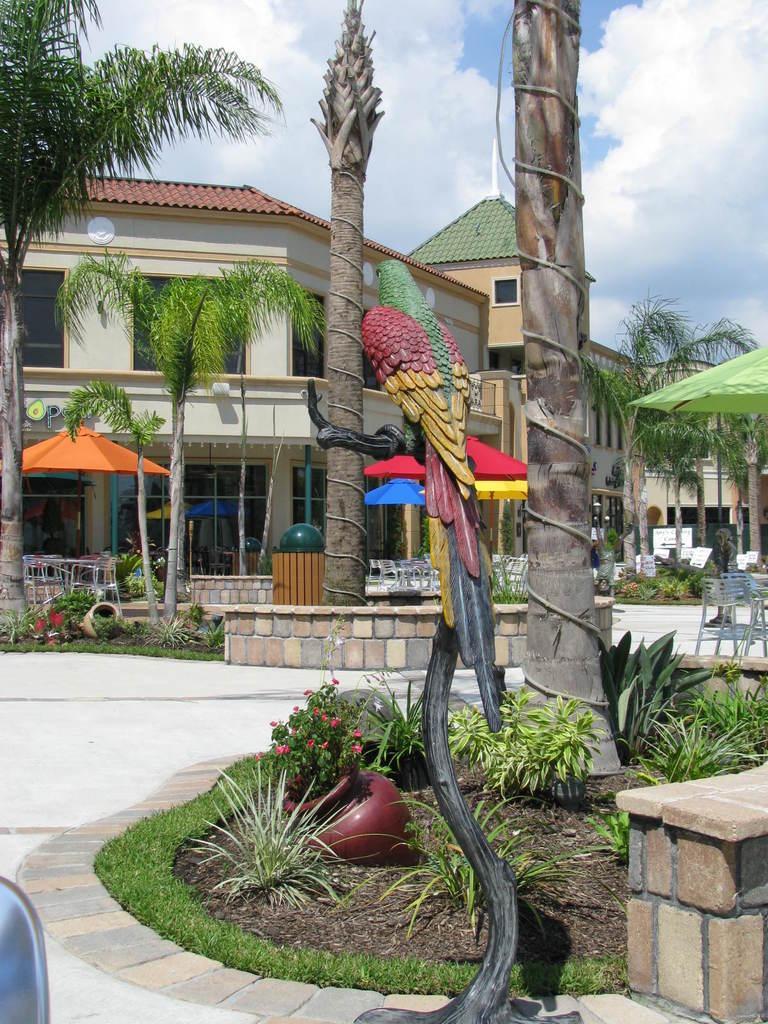In one or two sentences, can you explain what this image depicts? In this image there is a statue of a parrot on the tree, behind that there are trees, plants, flowers and there are a few canopies, beneath the canopy there are tables and chairs are arranged, there are a few boards with some text. In the background there are buildings and the sky. 